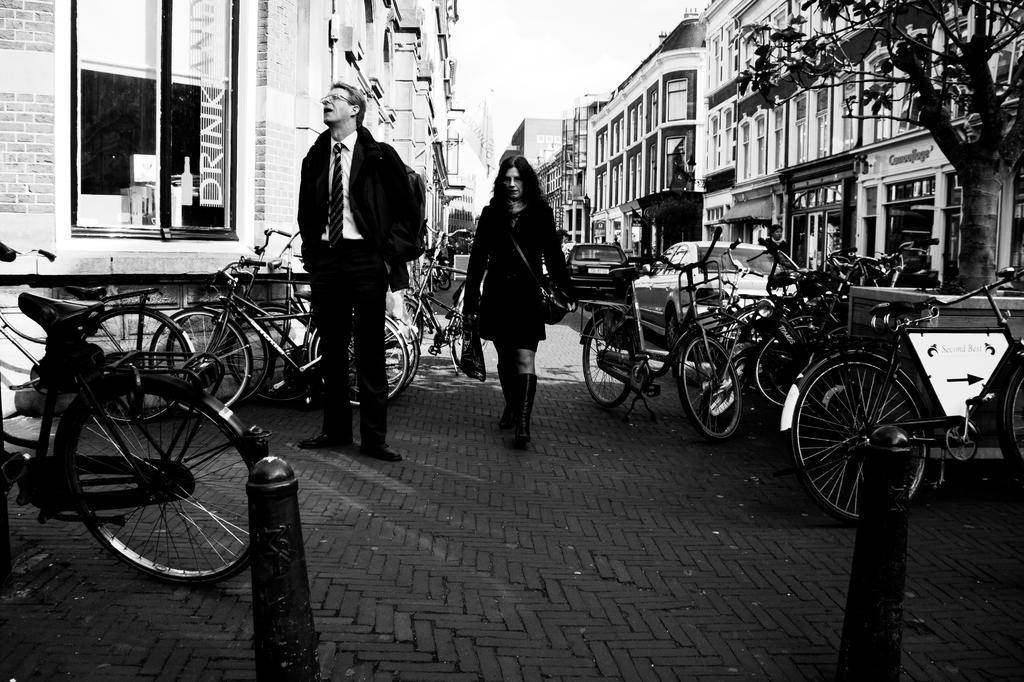Can you describe this image briefly? In this image we can see many buildings and they are having many windows. There are many vehicles in the image. There is some text and a logo on the glass at the left side of the image. There are few barriers in the image. There is a tree at the right side of the image. There is a sky in the image. 